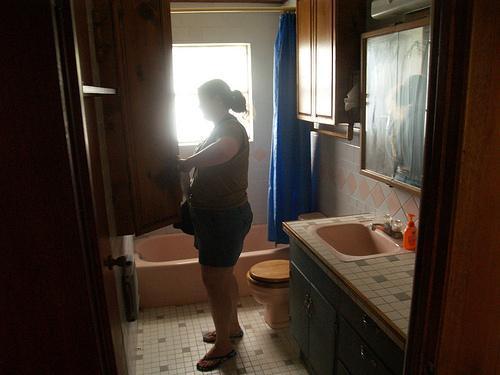How many people are there?
Give a very brief answer. 1. 